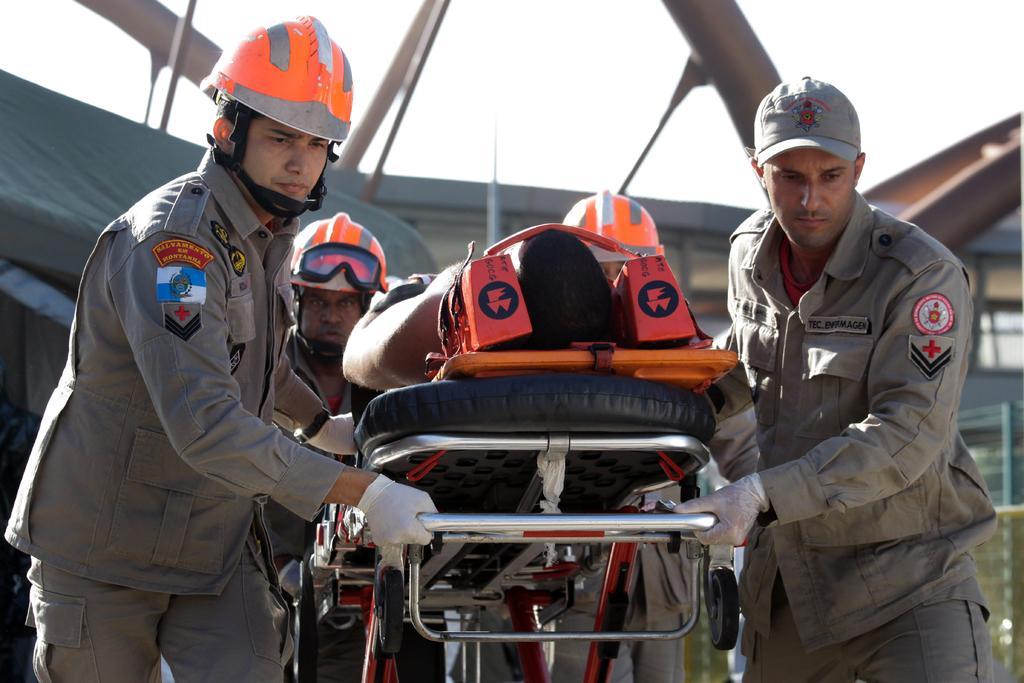In one or two sentences, can you explain what this image depicts? In this image we can see four persons holding a stretcher. On the stretcher we can see a person. Behind the persons we can see a tent and a building. At the top we can see the sky. 